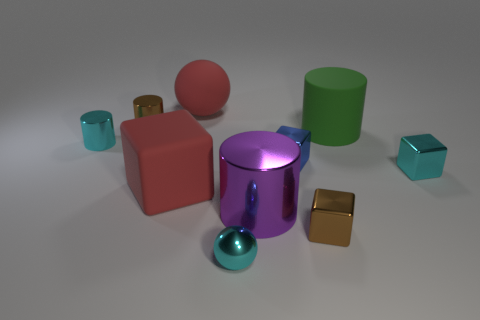Subtract all metal cubes. How many cubes are left? 1 Subtract all green cylinders. How many cylinders are left? 3 Subtract all yellow blocks. Subtract all red cylinders. How many blocks are left? 4 Subtract all balls. How many objects are left? 8 Subtract all big brown metal cylinders. Subtract all red cubes. How many objects are left? 9 Add 3 small blue objects. How many small blue objects are left? 4 Add 8 red things. How many red things exist? 10 Subtract 0 blue balls. How many objects are left? 10 